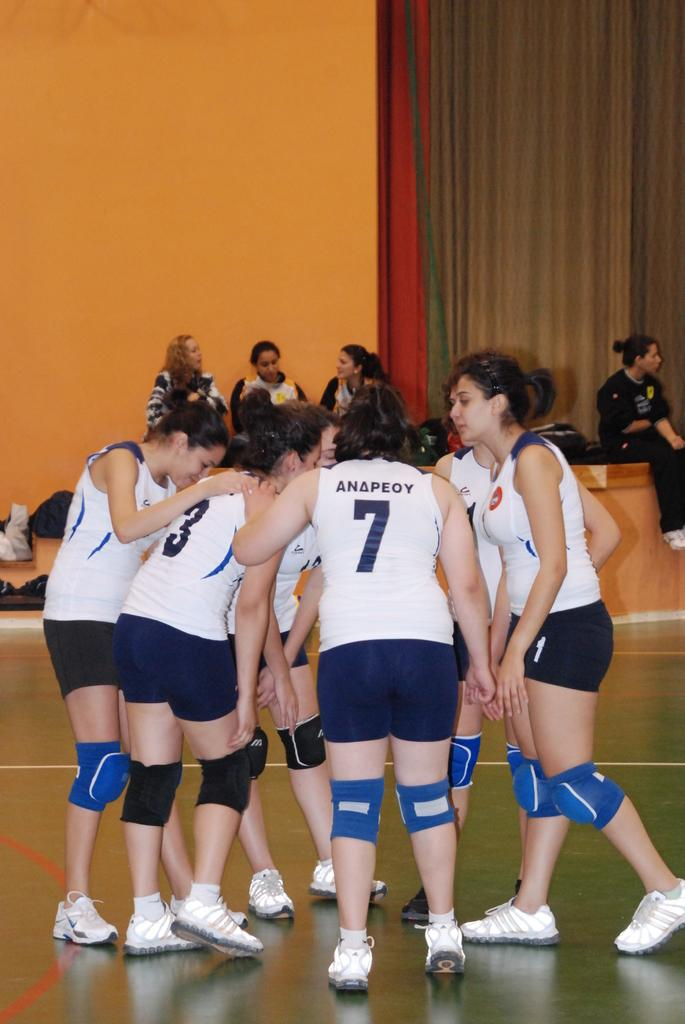Provide a one-sentence caption for the provided image. A team of volleyball players are huddled in a circle including number 3 and 7. 